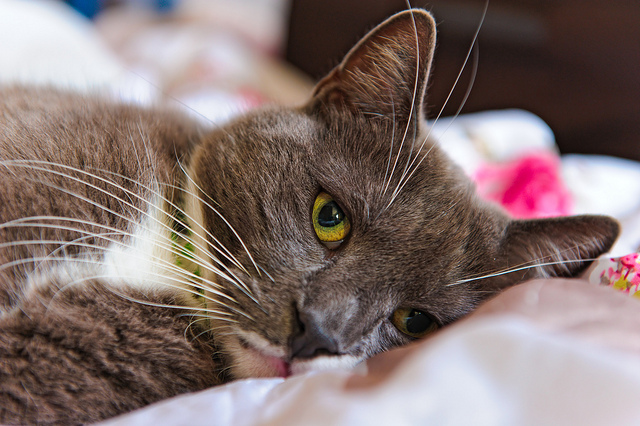What might the cat dream about? The cat might dream about chasing butterflies in a sunlit meadow, leaping gracefully in pursuit of the vibrant creatures. It might envision basking in a warm spot of sunlight, feeling the gentle rays against its fur. In another dream, the cat could be on a high-stakes mission, navigating the nooks and crannies of a mysterious mansion, uncovering secrets and hidden treasures. Let’s create a playful story about the cat’s day. Today, the cat woke up feeling adventurous. It stretched lazily on the bed before hopping down to explore the house. Its curiosity led it to a mysterious cardboard box in the living room. Upon investigating, the cat found a hidden door inside the box leading to a secret kitty kingdom. There, it was greeted by the feline monarch, who invited it to a grand feast with other kitty nobles. The day was filled with delicious treats, thrilling games of chase, and even a catnip ball! As the sun set in this mystical realm, the cat returned to its cozy bed in the real world, dreaming of the fantastic adventures it had.  The cat is the hero of an intergalactic mission. Describe its journey. As the brave captain of the starship Whisker, the cat embarked on an intergalactic mission to save the cosmos from the clutches of the sinister space rats. Equipped with advanced feline armor and a laser collar, Captain Whisker commanded a crew of diverse space kittens. Their journey took them through wormholes, past dazzling nebulae, and into the heart of the Dark Cheese Galaxy. Along the way, they encountered friendly alien species, each offering unique clues and support. The final showdown took place on the surface of a rogue planet made entirely of yarn. With cunning strategy and teamwork, Captain Whisker and its crew outsmarted the space rats, restoring peace to the galaxy and becoming interstellar legends celebrated in songs and tales across the universe. After a triumphant return to their home planet, the cat enjoyed a well-deserved rest, dreaming of more adventures among the stars. 